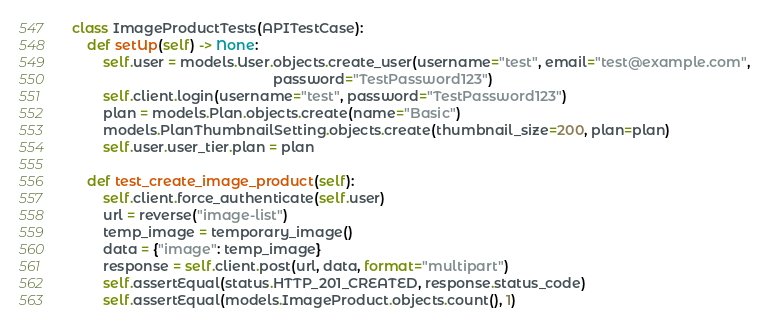Convert code to text. <code><loc_0><loc_0><loc_500><loc_500><_Python_>
class ImageProductTests(APITestCase):
    def setUp(self) -> None:
        self.user = models.User.objects.create_user(username="test", email="test@example.com",
                                                    password="TestPassword123")
        self.client.login(username="test", password="TestPassword123")
        plan = models.Plan.objects.create(name="Basic")
        models.PlanThumbnailSetting.objects.create(thumbnail_size=200, plan=plan)
        self.user.user_tier.plan = plan

    def test_create_image_product(self):
        self.client.force_authenticate(self.user)
        url = reverse("image-list")
        temp_image = temporary_image()
        data = {"image": temp_image}
        response = self.client.post(url, data, format="multipart")
        self.assertEqual(status.HTTP_201_CREATED, response.status_code)
        self.assertEqual(models.ImageProduct.objects.count(), 1)
</code> 